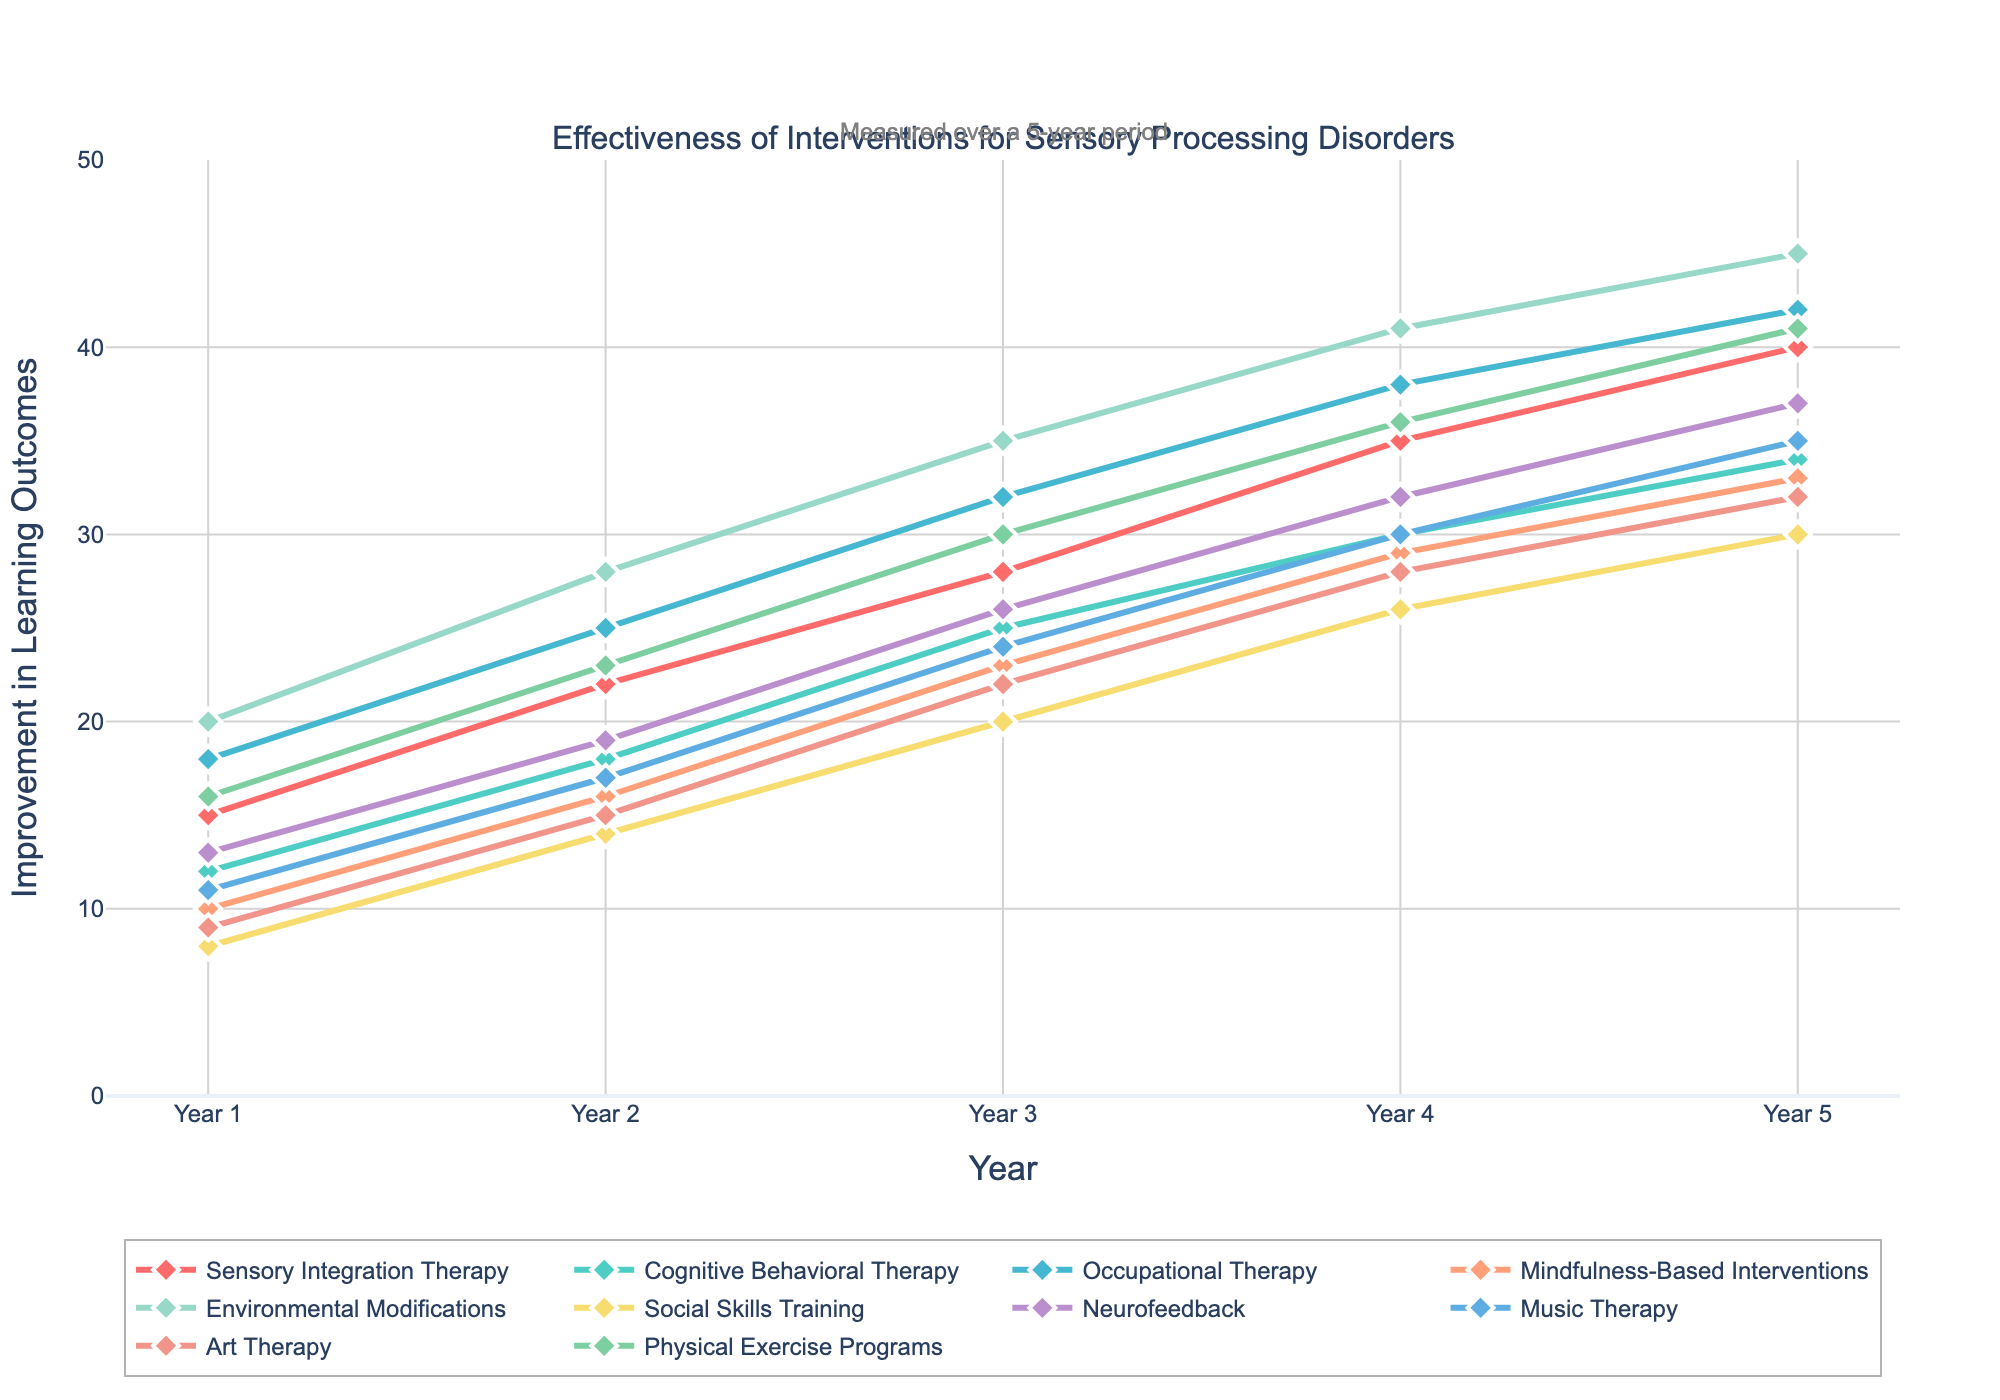Which intervention shows the greatest improvement in learning outcomes by the end of Year 5? First, observe the y-values for all interventions at Year 5. Environmental Modifications shows 45, which is the highest among all interventions
Answer: Environmental Modifications What is the difference in improvement between Sensory Integration Therapy and Mindfulness-Based Interventions in Year 3? Look at the y-values for Sensory Integration Therapy and Mindfulness-Based Interventions in Year 3, which are 28 and 23 respectively. Subtract the smaller value from the larger one: 28 - 23 = 5
Answer: 5 Which two interventions have the closest improvement in learning outcomes in Year 4? Compare the y-values for all interventions in Year 4. Occupational Therapy and Physical Exercise Programs both show an improvement of 36, which is the closest match
Answer: Occupational Therapy and Physical Exercise Programs What is the average improvement in learning outcomes across all interventions by Year 2? Sum all the y-values for Year 2 and divide by the number of interventions. Calculation: (22 + 18 + 25 + 16 + 28 + 14 + 19 + 17 + 15 + 23) / 10 = 197 / 10 = 19.7
Answer: 19.7 By how much did Neurofeedback improve from Year 1 to Year 5? Look at the y-values for Neurofeedback in Year 1 and Year 5, which are 13 and 37 respectively. Subtract the Year 1 value from the Year 5 value: 37 - 13 = 24
Answer: 24 Which intervention showed the least improvement in Year 5? Look at the y-values for all interventions in Year 5. Social Skills Training shows 30, which is the lowest among all interventions
Answer: Social Skills Training Between Cognitive Behavioral Therapy and Music Therapy, which intervention shows a steeper improvement from Year 1 to Year 3? For Cognitive Behavioral Therapy, the increase from Year 1 to Year 3 is 25 - 12 = 13. For Music Therapy, the increase from Year 1 to Year 3 is 24 - 11 = 13. Both have the same improvement
Answer: Both have the same improvement What is the average yearly improvement for Occupational Therapy over the 5-year period? First, find the total improvement from Year 1 to Year 5: 42 - 18 = 24. Divide this by the number of years: 24 / 5 = 4.8
Answer: 4.8 Which intervention had a higher improvement in Year 3: Art Therapy or Social Skills Training? Look at the y-values for Art Therapy and Social Skills Training in Year 3, which are 22 and 20 respectively. Art Therapy has a higher value
Answer: Art Therapy 